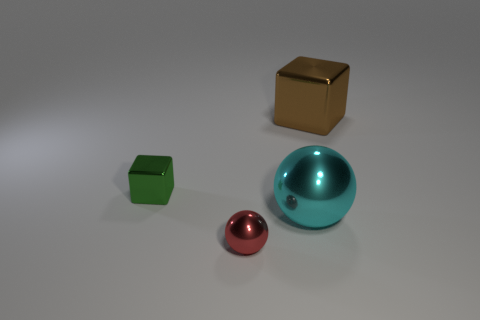Add 2 tiny purple matte objects. How many objects exist? 6 Subtract all green metal things. Subtract all shiny blocks. How many objects are left? 1 Add 2 brown metallic objects. How many brown metallic objects are left? 3 Add 4 big cyan balls. How many big cyan balls exist? 5 Subtract 1 cyan balls. How many objects are left? 3 